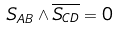<formula> <loc_0><loc_0><loc_500><loc_500>S _ { A B } \wedge \overline { S _ { C D } } = 0</formula> 